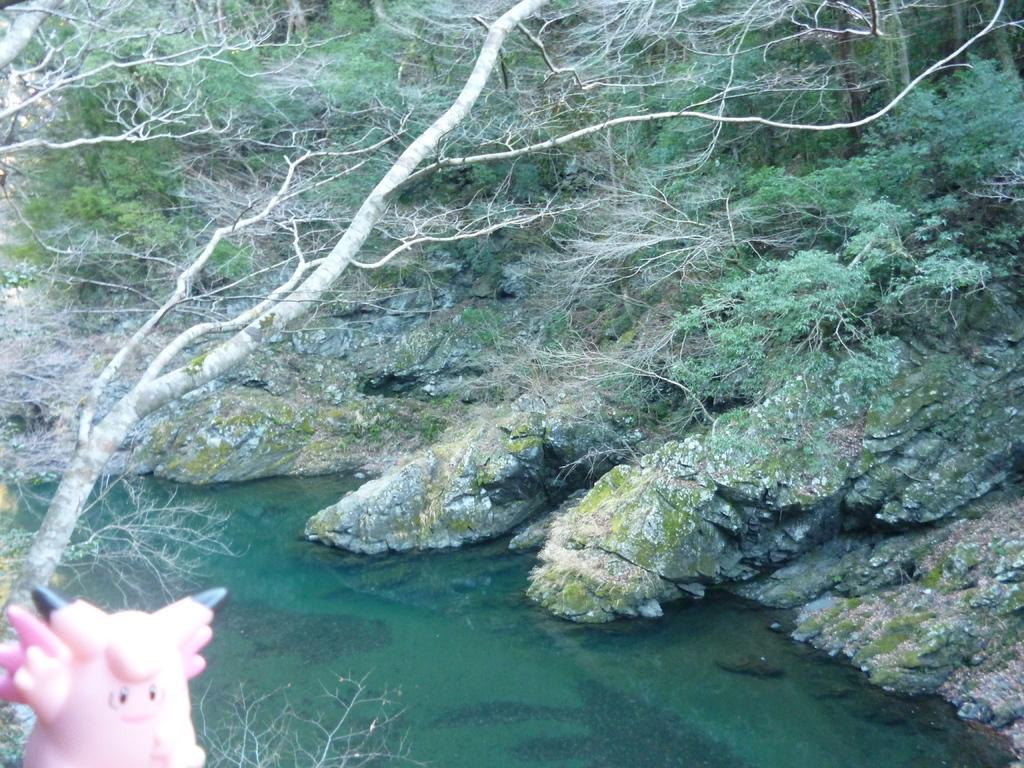What is the main object in the front of the image? There is a toy in the front of the image. What can be seen in the middle of the image? There is water in the center of the image. What type of natural scenery is visible in the background of the image? There are trees in the background of the image. Where is the cellar located in the image? There is no cellar present in the image. What type of birds can be seen flying over the water in the image? There are no birds visible in the image; it only features a toy, water, and trees. 